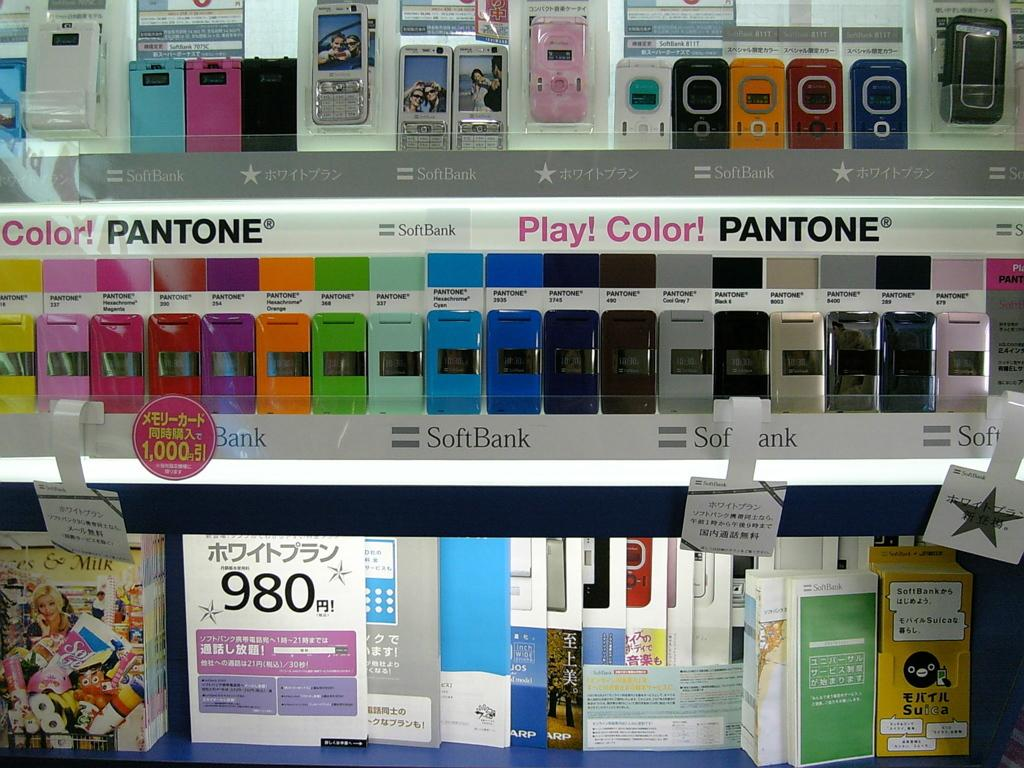<image>
Provide a brief description of the given image. a wall of different colored panels with a label that says 'softbank' on it 